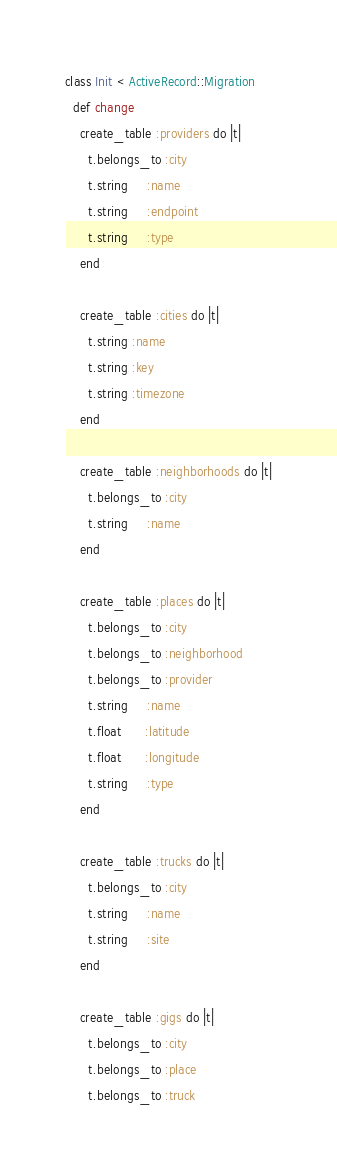<code> <loc_0><loc_0><loc_500><loc_500><_Ruby_>class Init < ActiveRecord::Migration
  def change
    create_table :providers do |t|
      t.belongs_to :city
      t.string     :name
      t.string     :endpoint
      t.string     :type
    end

    create_table :cities do |t|
      t.string :name
      t.string :key
      t.string :timezone
    end

    create_table :neighborhoods do |t|
      t.belongs_to :city
      t.string     :name
    end

    create_table :places do |t|
      t.belongs_to :city
      t.belongs_to :neighborhood
      t.belongs_to :provider
      t.string     :name
      t.float      :latitude
      t.float      :longitude
      t.string     :type
    end

    create_table :trucks do |t|
      t.belongs_to :city
      t.string     :name
      t.string     :site
    end

    create_table :gigs do |t|
      t.belongs_to :city
      t.belongs_to :place
      t.belongs_to :truck</code> 